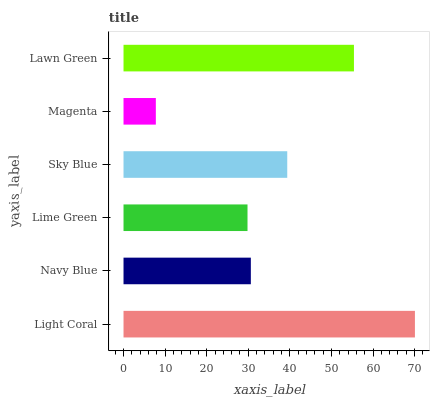Is Magenta the minimum?
Answer yes or no. Yes. Is Light Coral the maximum?
Answer yes or no. Yes. Is Navy Blue the minimum?
Answer yes or no. No. Is Navy Blue the maximum?
Answer yes or no. No. Is Light Coral greater than Navy Blue?
Answer yes or no. Yes. Is Navy Blue less than Light Coral?
Answer yes or no. Yes. Is Navy Blue greater than Light Coral?
Answer yes or no. No. Is Light Coral less than Navy Blue?
Answer yes or no. No. Is Sky Blue the high median?
Answer yes or no. Yes. Is Navy Blue the low median?
Answer yes or no. Yes. Is Lawn Green the high median?
Answer yes or no. No. Is Magenta the low median?
Answer yes or no. No. 